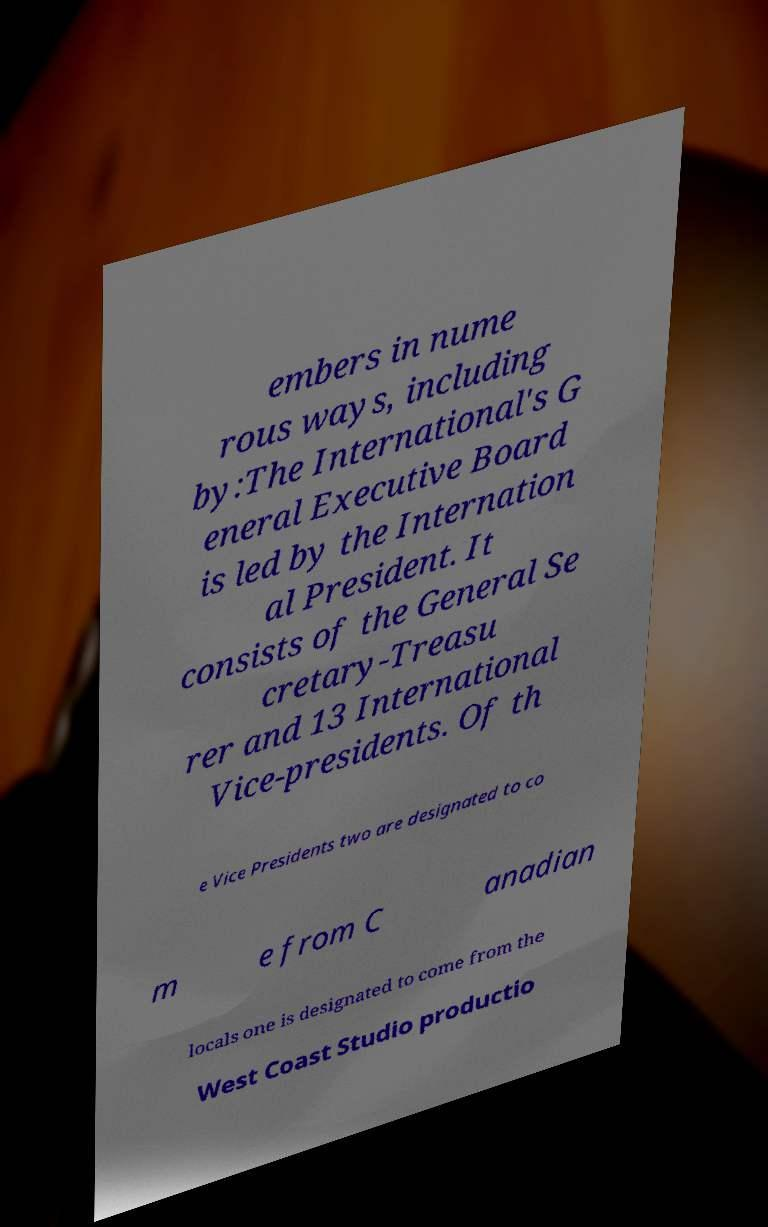I need the written content from this picture converted into text. Can you do that? embers in nume rous ways, including by:The International's G eneral Executive Board is led by the Internation al President. It consists of the General Se cretary-Treasu rer and 13 International Vice-presidents. Of th e Vice Presidents two are designated to co m e from C anadian locals one is designated to come from the West Coast Studio productio 